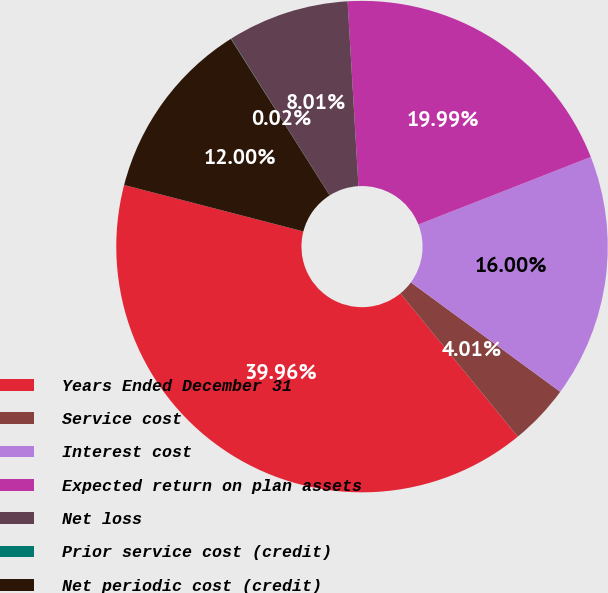<chart> <loc_0><loc_0><loc_500><loc_500><pie_chart><fcel>Years Ended December 31<fcel>Service cost<fcel>Interest cost<fcel>Expected return on plan assets<fcel>Net loss<fcel>Prior service cost (credit)<fcel>Net periodic cost (credit)<nl><fcel>39.96%<fcel>4.01%<fcel>16.0%<fcel>19.99%<fcel>8.01%<fcel>0.02%<fcel>12.0%<nl></chart> 